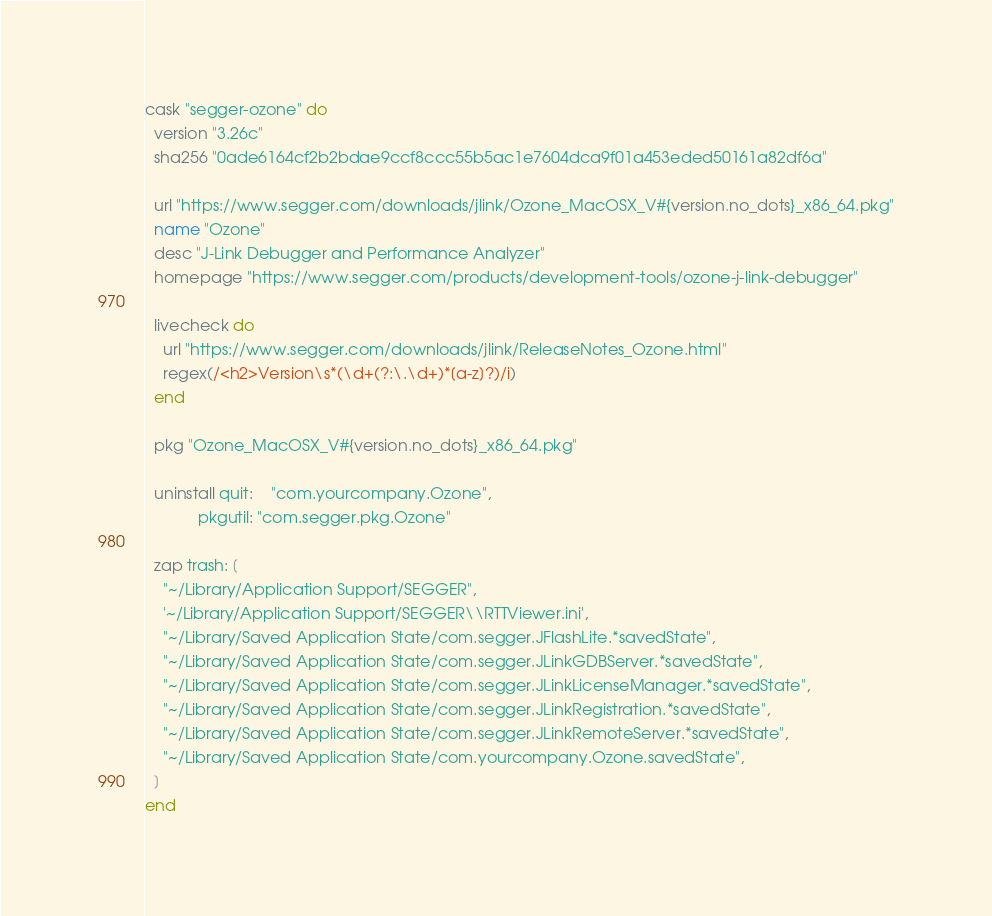Convert code to text. <code><loc_0><loc_0><loc_500><loc_500><_Ruby_>cask "segger-ozone" do
  version "3.26c"
  sha256 "0ade6164cf2b2bdae9ccf8ccc55b5ac1e7604dca9f01a453eded50161a82df6a"

  url "https://www.segger.com/downloads/jlink/Ozone_MacOSX_V#{version.no_dots}_x86_64.pkg"
  name "Ozone"
  desc "J-Link Debugger and Performance Analyzer"
  homepage "https://www.segger.com/products/development-tools/ozone-j-link-debugger"

  livecheck do
    url "https://www.segger.com/downloads/jlink/ReleaseNotes_Ozone.html"
    regex(/<h2>Version\s*(\d+(?:\.\d+)*[a-z]?)/i)
  end

  pkg "Ozone_MacOSX_V#{version.no_dots}_x86_64.pkg"

  uninstall quit:    "com.yourcompany.Ozone",
            pkgutil: "com.segger.pkg.Ozone"

  zap trash: [
    "~/Library/Application Support/SEGGER",
    '~/Library/Application Support/SEGGER\\RTTViewer.ini',
    "~/Library/Saved Application State/com.segger.JFlashLite.*savedState",
    "~/Library/Saved Application State/com.segger.JLinkGDBServer.*savedState",
    "~/Library/Saved Application State/com.segger.JLinkLicenseManager.*savedState",
    "~/Library/Saved Application State/com.segger.JLinkRegistration.*savedState",
    "~/Library/Saved Application State/com.segger.JLinkRemoteServer.*savedState",
    "~/Library/Saved Application State/com.yourcompany.Ozone.savedState",
  ]
end
</code> 